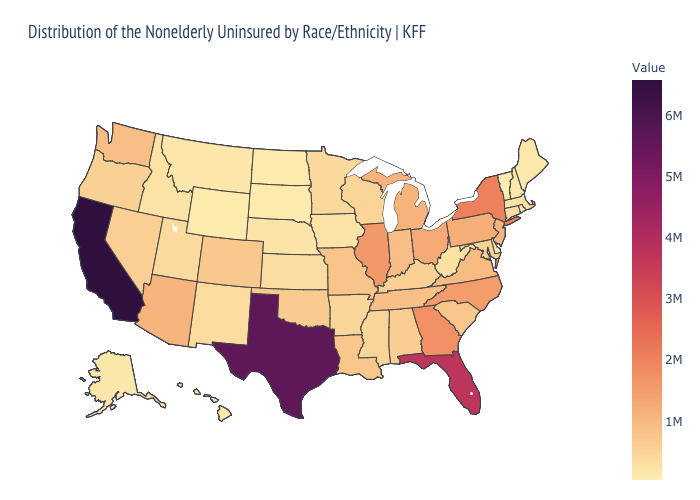Does Missouri have a higher value than North Carolina?
Quick response, please. No. Is the legend a continuous bar?
Be succinct. Yes. Is the legend a continuous bar?
Give a very brief answer. Yes. Does the map have missing data?
Be succinct. No. Does Virginia have a lower value than Florida?
Keep it brief. Yes. 